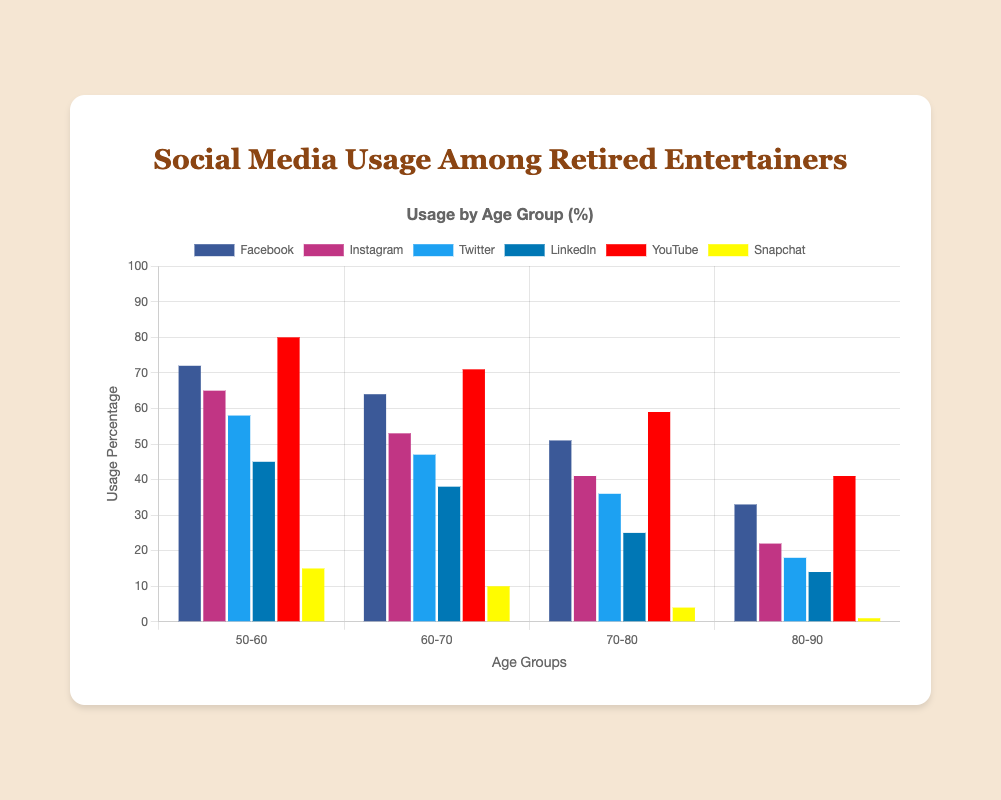Which age group uses YouTube the most? The bar corresponding to YouTube in the "50-60" age group is the highest among all age groups for YouTube.
Answer: 50-60 Which social media platform has the least usage among the "80-90" age group? The bar corresponding to "Snapchat" in the "80-90" age group is the shortest, indicating the least usage.
Answer: Snapchat Compare the usage of Facebook and LinkedIn for the "60-70" age group. Which one is used more? The bar for Facebook in the "60-70" age group is taller than the bar for LinkedIn.
Answer: Facebook What is the total social media usage for the "70-80" age group across all platforms? Add up the values for each platform in the "70-80" age group: 51 (Facebook) + 41 (Instagram) + 36 (Twitter) + 25 (LinkedIn) + 59 (YouTube) + 4 (Snapchat) = 216
Answer: 216 What is the average usage percentage of Twitter across all age groups? Add the Twitter usage values across all age groups and divide by the number of age groups: (58 + 47 + 36 + 18) / 4 = 159 / 4 = 39.75
Answer: 39.75 Which social media platform sees the greatest decline in usage percentage from the "50-60" age group to the "80-90" age group? Calculate the decline for each platform: 
- Facebook: 72 - 33 = 39
- Instagram: 65 - 22 = 43
- Twitter: 58 - 18 = 40
- LinkedIn: 45 - 14 = 31
- YouTube: 80 - 41 = 39
- Snapchat: 15 - 1 = 14
Instagram has the highest decline.
Answer: Instagram What percentage more is YouTube used compared to Twitter in the "70-80" age group? Subtract the Twitter usage value from the YouTube usage value for the "70-80" age group and then divide by the Twitter value: (59 - 36) / 36 * 100 = 23 / 36 * 100 ≈ 63.89
Answer: ~63.89 What is the difference in usage percentage between Facebook and Instagram for the "50-60" age group? Subtract the Instagram value from the Facebook value for the "50-60" age group: 72 - 65 = 7
Answer: 7 Which age group has the lowest average social media usage across all platforms? Calculate the average usage for each age group and compare:
- 50-60: (72 + 65 + 58 + 45 + 80 + 15) / 6 = 335 / 6 ≈ 55.83
- 60-70: (64 + 53 + 47 + 38 + 71 + 10) / 6 = 283 / 6 ≈ 47.17
- 70-80: (51 + 41 + 36 + 25 + 59 + 4) / 6 = 216 / 6 = 36
- 80-90: (33 + 22 + 18 + 14 + 41 + 1) / 6 = 129 / 6 ≈ 21.5
The "80-90" age group has the lowest average.
Answer: 80-90 